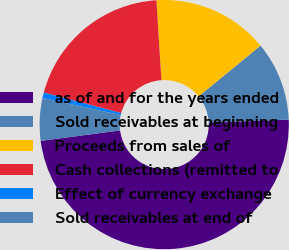Convert chart. <chart><loc_0><loc_0><loc_500><loc_500><pie_chart><fcel>as of and for the years ended<fcel>Sold receivables at beginning<fcel>Proceeds from sales of<fcel>Cash collections (remitted to<fcel>Effect of currency exchange<fcel>Sold receivables at end of<nl><fcel>48.55%<fcel>10.29%<fcel>15.07%<fcel>19.86%<fcel>0.72%<fcel>5.51%<nl></chart> 